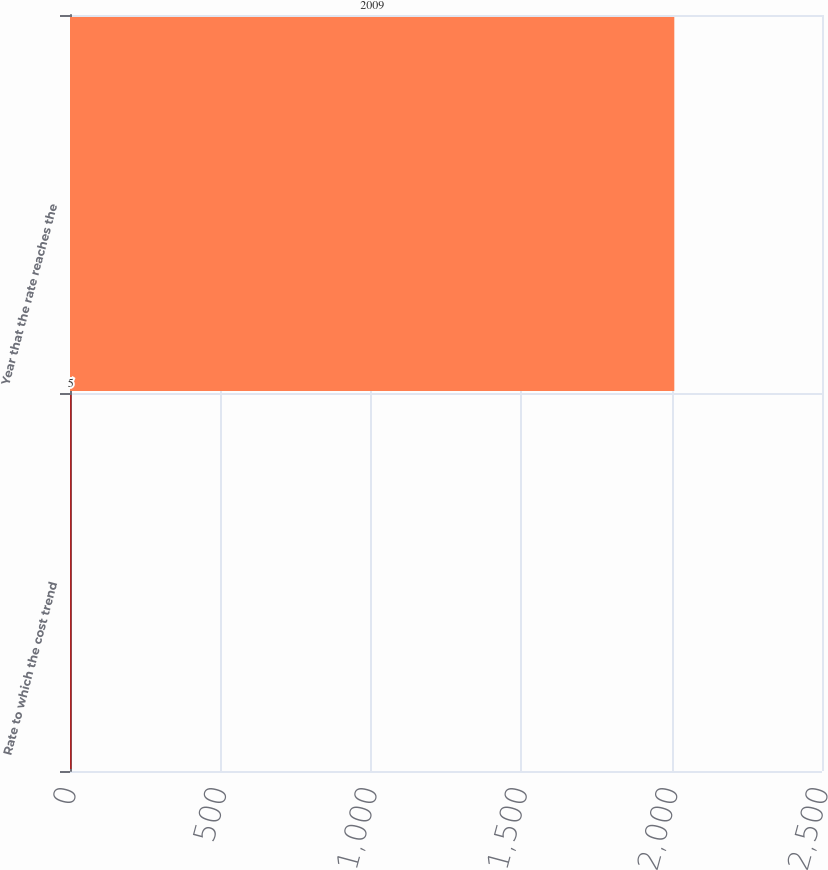Convert chart. <chart><loc_0><loc_0><loc_500><loc_500><bar_chart><fcel>Rate to which the cost trend<fcel>Year that the rate reaches the<nl><fcel>5<fcel>2009<nl></chart> 